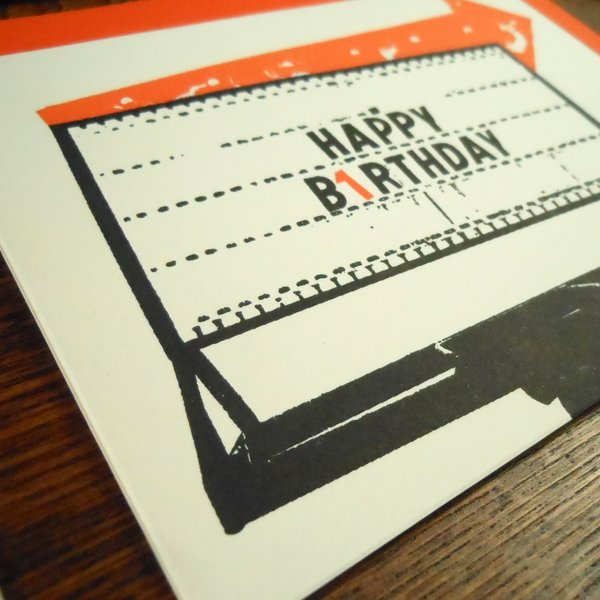If this card could speak, what story do you think it would tell about its journey? If this card could speak, it might recount a journey filled with emotion, nostalgia, and personal connections. It could start its tale in a quaint, little shop filled with vintage memorabilia, where it catches the eye of someone with a love for the past. Its journey began as it was carefully selected to celebrate a special occasion. As it found its way into the hands of its giver, it could feel the anticipation and joy of being associated with a heartfelt gesture. Upon being delivered, it witnessed the surprise and happiness of the recipient, becoming a cherished keepsake of the day. It would speak of the moments it facilitated - perhaps bringing stories of yesteryears to life, being a part of laughter shared over memories, and witnessing the deepening of bonds. This card would tell a story not just of its own existence, but of the human connections it helped to celebrate and cherish. What creative activities could one do with this vintage card as a starting point? One creative activity could be using the card as inspiration for a vintage-themed scrapbook. Collect old photographs, postcards, and handwritten letters to create a nostalgic collage that tells a story of a bygone era. Another activity could be crafting a personalized journal or notebook, with the card serving as the cover or centerpiece. You could also use it as a prop in a vintage-styled photo shoot, capturing the essence of the past in your pictures. If you enjoy writing, you could compose a short story or poem inspired by the card, imagining the lives and relationships it touched. Hosting a retro-themed party with typewriter-styled invitations and decorations mimicking the card’s aesthetic could also be a fun and engaging way to celebrate its vintage charm. 